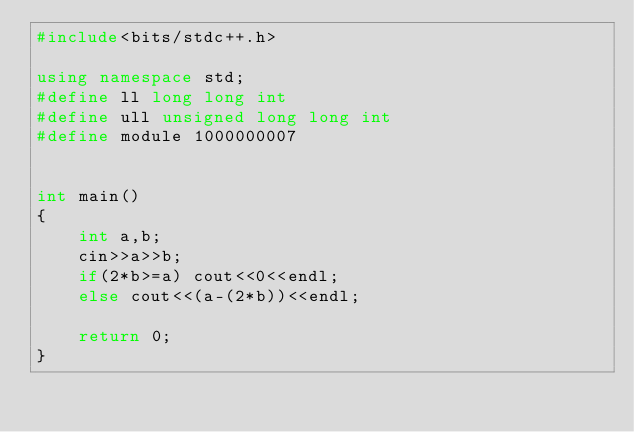<code> <loc_0><loc_0><loc_500><loc_500><_C++_>#include<bits/stdc++.h>

using namespace std;
#define ll long long int
#define ull unsigned long long int
#define module 1000000007


int main()
{
    int a,b;
    cin>>a>>b;
    if(2*b>=a) cout<<0<<endl;
    else cout<<(a-(2*b))<<endl;
    
    return 0;
}</code> 